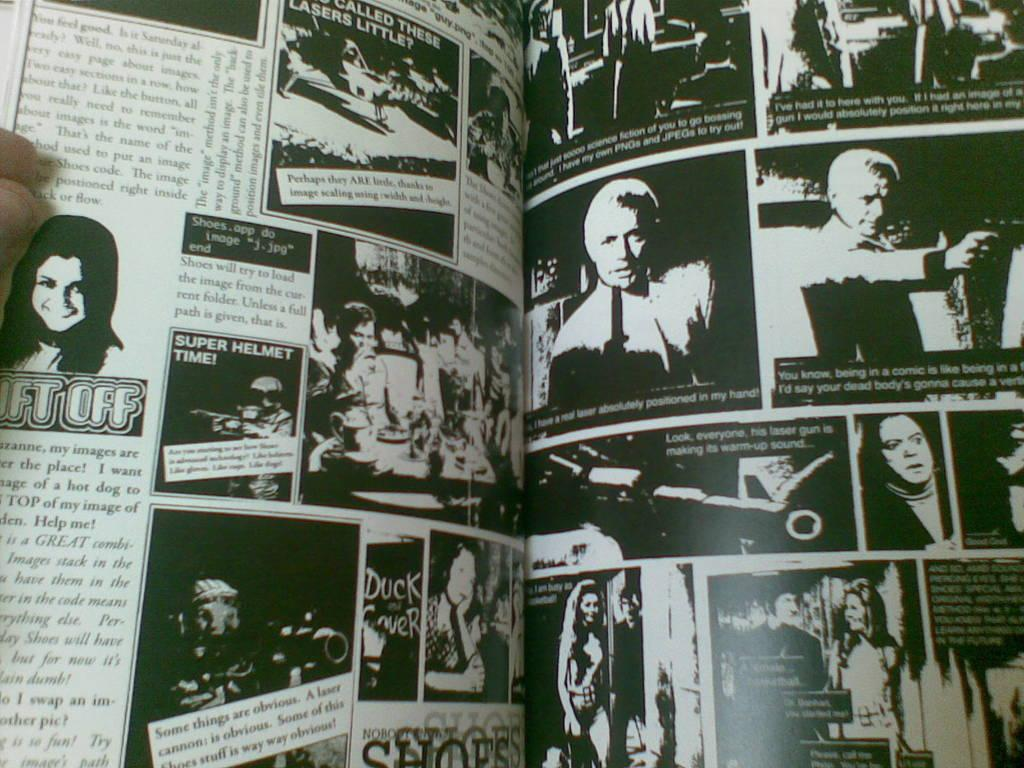What part of the human body is visible in the image? There is a human hand in the image. What object is the hand holding or interacting with? The hand is holding or interacting with a book in the image. What can be found on the pages of the book? The book has text and pictures on its pages. What type of stem can be seen growing from the mouth of the person in the image? There is no person or stem present in the image; it only features a human hand and a book. 